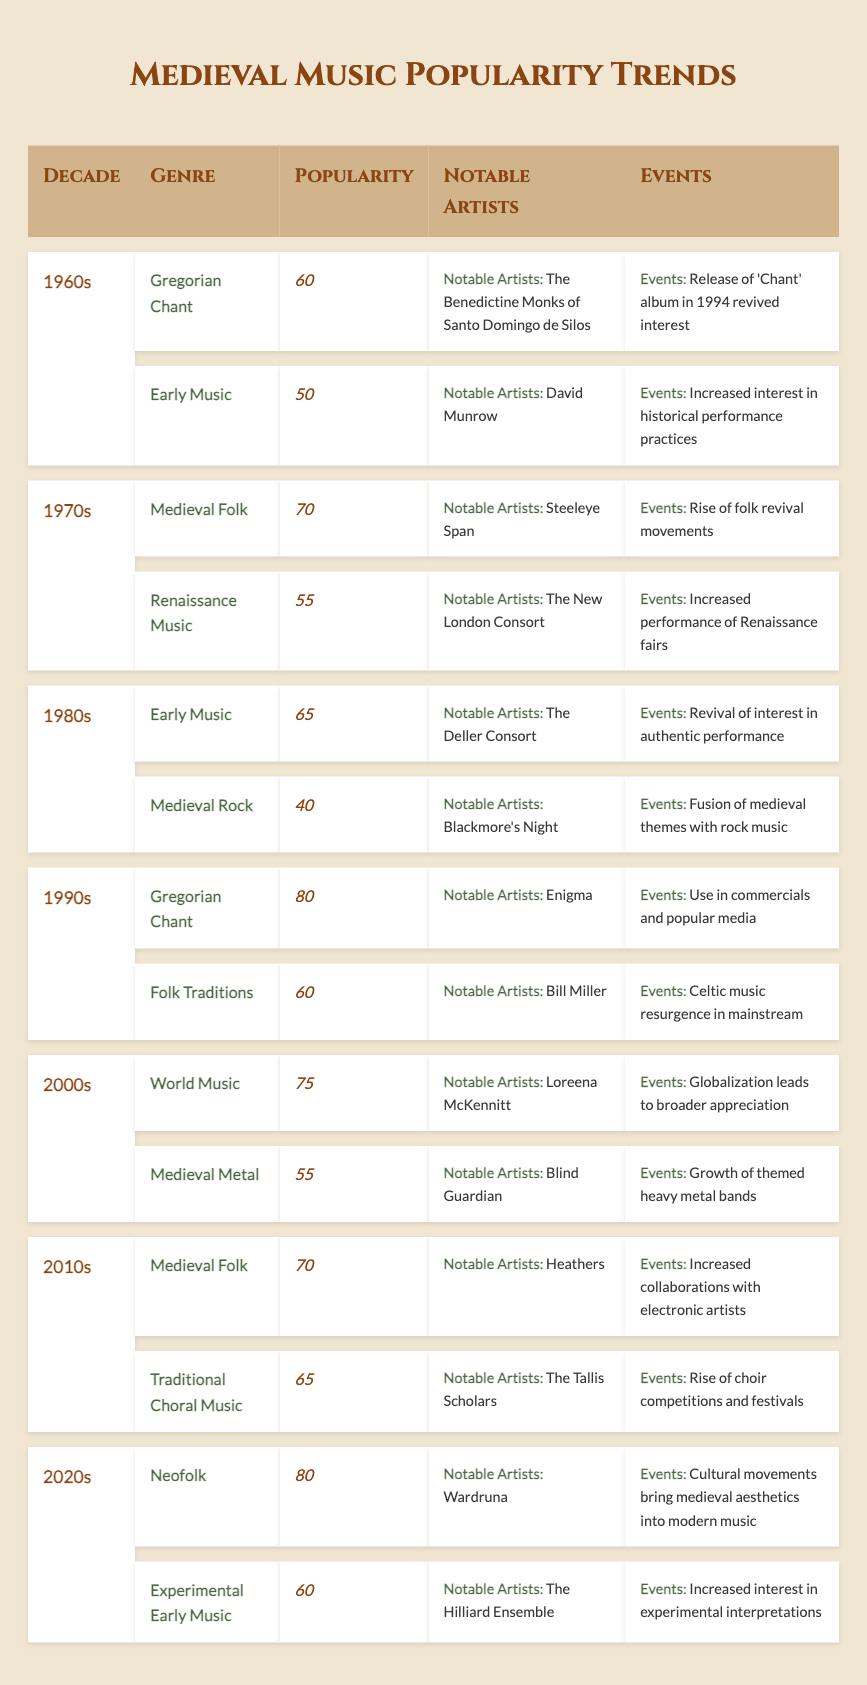What genre had the highest popularity index in the 1990s? In the 1990s, the genres listed are Gregorian Chant with a popularity index of 80 and Folk Traditions with a popularity index of 60. Therefore, Gregorian Chant had the highest popularity index for that decade.
Answer: Gregorian Chant Which decade had the lowest popularity index for Medieval Rock? The only decade that features Medieval Rock is the 1980s, where it has a popularity index of 40. Therefore, it represents the lowest popularity index for that genre across all decades since it's the only entry.
Answer: 1980s What is the average popularity index of Medieval Folk across the decades? Medieval Folk appears in the 1970s with a popularity index of 70 and again in the 2010s with a popularity index of 70. To find the average, we sum them up (70 + 70 = 140) and divide by the number of data points (2): 140 / 2 = 70.
Answer: 70 Is it true that the popularity index for Early Music increased from the 1960s to the 1980s? In the 1960s, Early Music had a popularity index of 50, while in the 1980s, it increased to 65. Thus, it is true that its popularity index increased over these decades.
Answer: Yes Which genre experienced a revival through globalization in the 2000s? In the 2000s, World Music is noted for experiencing a revival due to globalization, which leads to broader appreciation of the genre.
Answer: World Music What decade saw a resurgence of Gregorian Chant use in popular media, and what was its popularity index? Gregorian Chant was noted for its resurgence in the 1990s, with a popularity index of 80, largely attributed to its use in commercials and popular media.
Answer: 1990s, 80 How many genres have a popularity index of 60 or above in the 2020s? In the 2020s, Neofolk has a popularity index of 80 and Experimental Early Music has a popularity index of 60. Therefore, there are two genres above 60.
Answer: 2 What notable artist is associated with Medieval Folk in the 2010s? In the 2010s, the genre Medieval Folk is associated with the artist Heathers.
Answer: Heathers What event is linked to the rise of choir competitions in the 2010s? In the 2010s, the event linked to Traditional Choral Music was the rise of choir competitions and festivals.
Answer: Rise of choir competitions In which decade did Gregorian Chant experience a significant increase in popularity, and which artist contributed to this? Gregorian Chant saw a significant increase in popularity in the 1990s, primarily through the artist Enigma.
Answer: 1990s, Enigma What was the difference in popularity index between Medieval Folk in the 1970s and Medieval Metal in the 2000s? Medieval Folk in the 1970s had a popularity index of 70, while Medieval Metal in the 2000s had a popularity index of 55. The difference is 70 - 55 = 15.
Answer: 15 